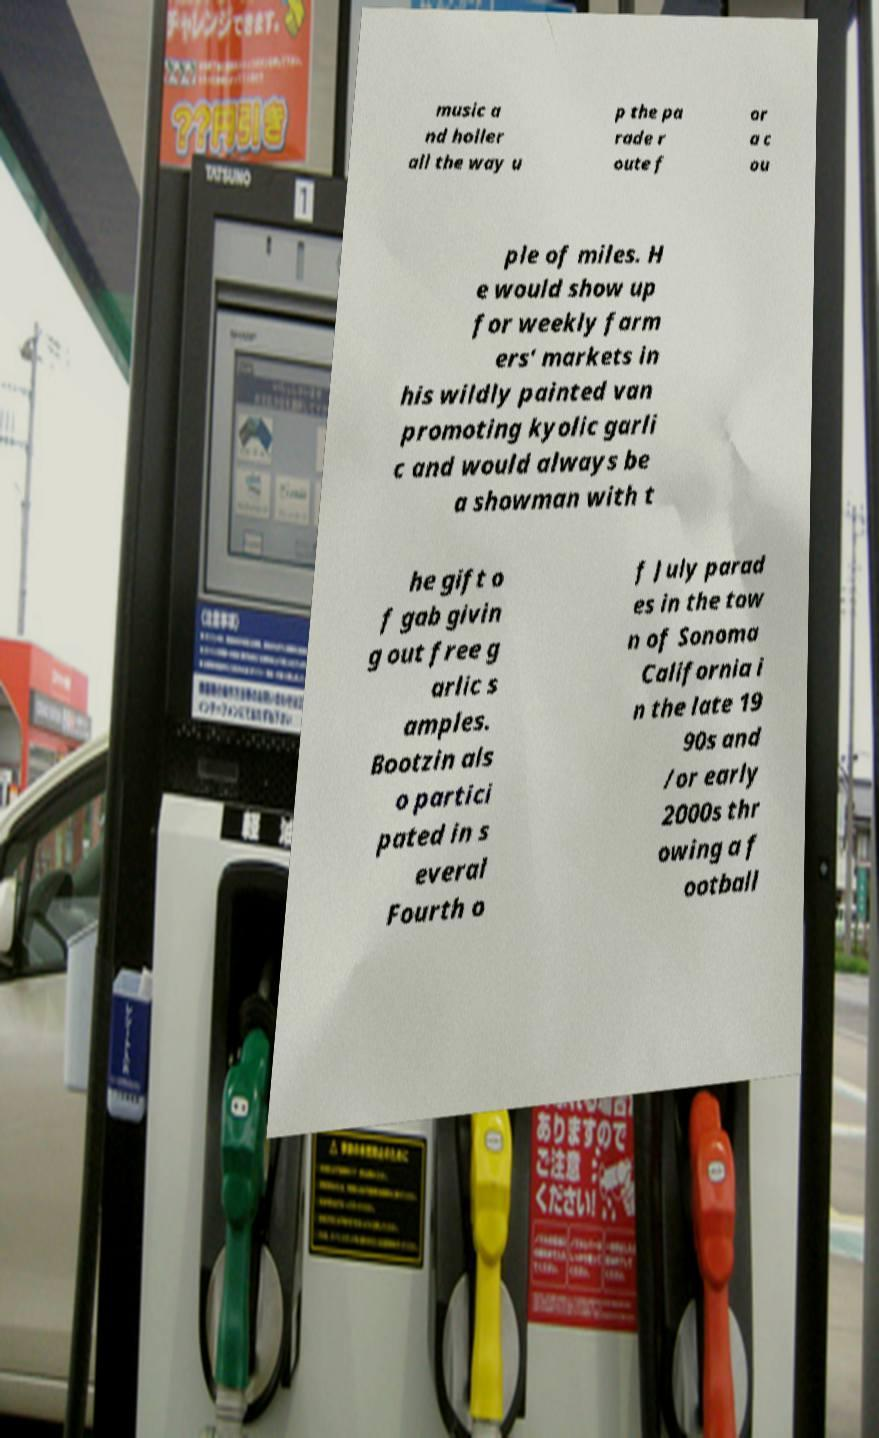Can you read and provide the text displayed in the image?This photo seems to have some interesting text. Can you extract and type it out for me? music a nd holler all the way u p the pa rade r oute f or a c ou ple of miles. H e would show up for weekly farm ers' markets in his wildly painted van promoting kyolic garli c and would always be a showman with t he gift o f gab givin g out free g arlic s amples. Bootzin als o partici pated in s everal Fourth o f July parad es in the tow n of Sonoma California i n the late 19 90s and /or early 2000s thr owing a f ootball 